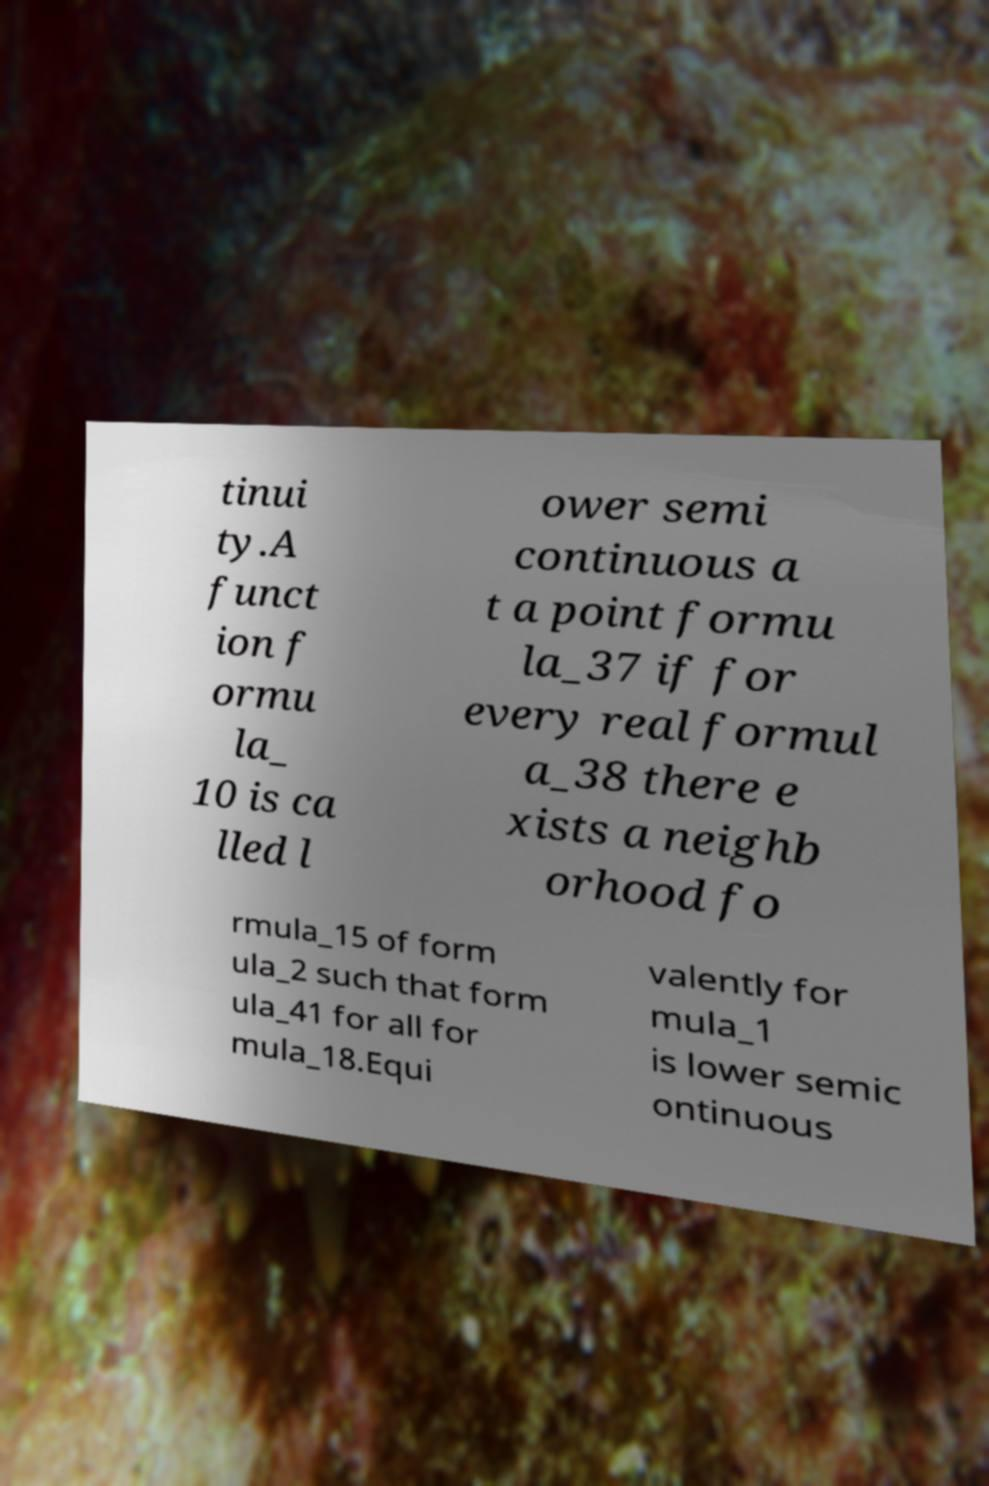What messages or text are displayed in this image? I need them in a readable, typed format. tinui ty.A funct ion f ormu la_ 10 is ca lled l ower semi continuous a t a point formu la_37 if for every real formul a_38 there e xists a neighb orhood fo rmula_15 of form ula_2 such that form ula_41 for all for mula_18.Equi valently for mula_1 is lower semic ontinuous 